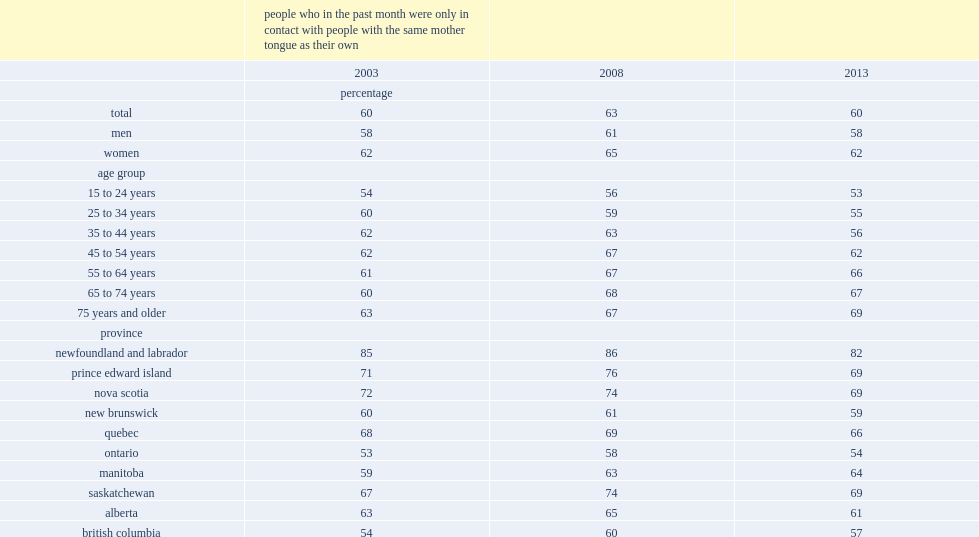In 2013,what is the percentage of canadians who only had contact, in the past month, with friends who shared the same mother tongue? 60.0. In 2003,what is the percentage of canadians who only had contact, in the past month, with friends who shared the same mother tongue? 60.0. What is the percentage of people having contact only with friends sharing the same mother tongue in ontario in 2013? 54.0. Which province recorded the smallest proportion of people having contact only with friends sharing the same mother tongue in 2013? Ontario. What is the percentage of people having contact only with friends sharing the same mother tongue in newfoundland and labrador in 2013? 82.0. Which province recorded the highest proportion of people having contact only with friends sharing the same mother tongue in 2013? Newfoundland and labrador. 